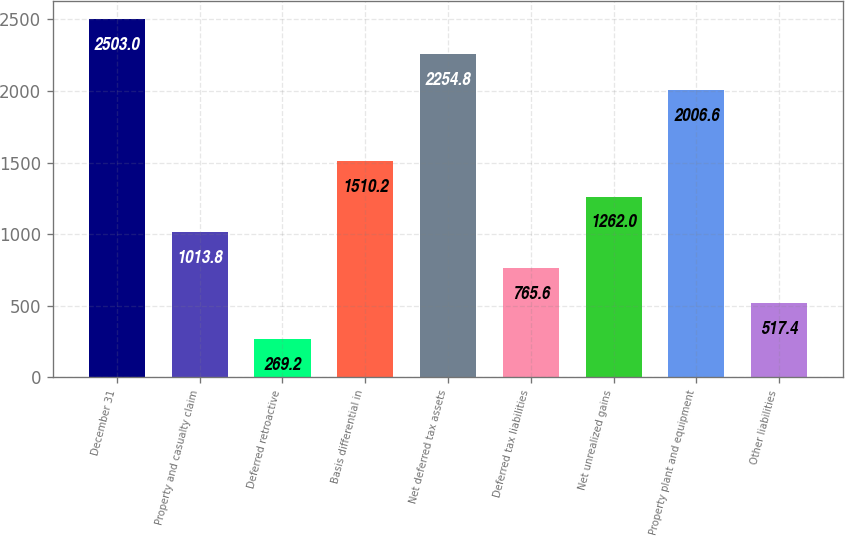Convert chart. <chart><loc_0><loc_0><loc_500><loc_500><bar_chart><fcel>December 31<fcel>Property and casualty claim<fcel>Deferred retroactive<fcel>Basis differential in<fcel>Net deferred tax assets<fcel>Deferred tax liabilities<fcel>Net unrealized gains<fcel>Property plant and equipment<fcel>Other liabilities<nl><fcel>2503<fcel>1013.8<fcel>269.2<fcel>1510.2<fcel>2254.8<fcel>765.6<fcel>1262<fcel>2006.6<fcel>517.4<nl></chart> 